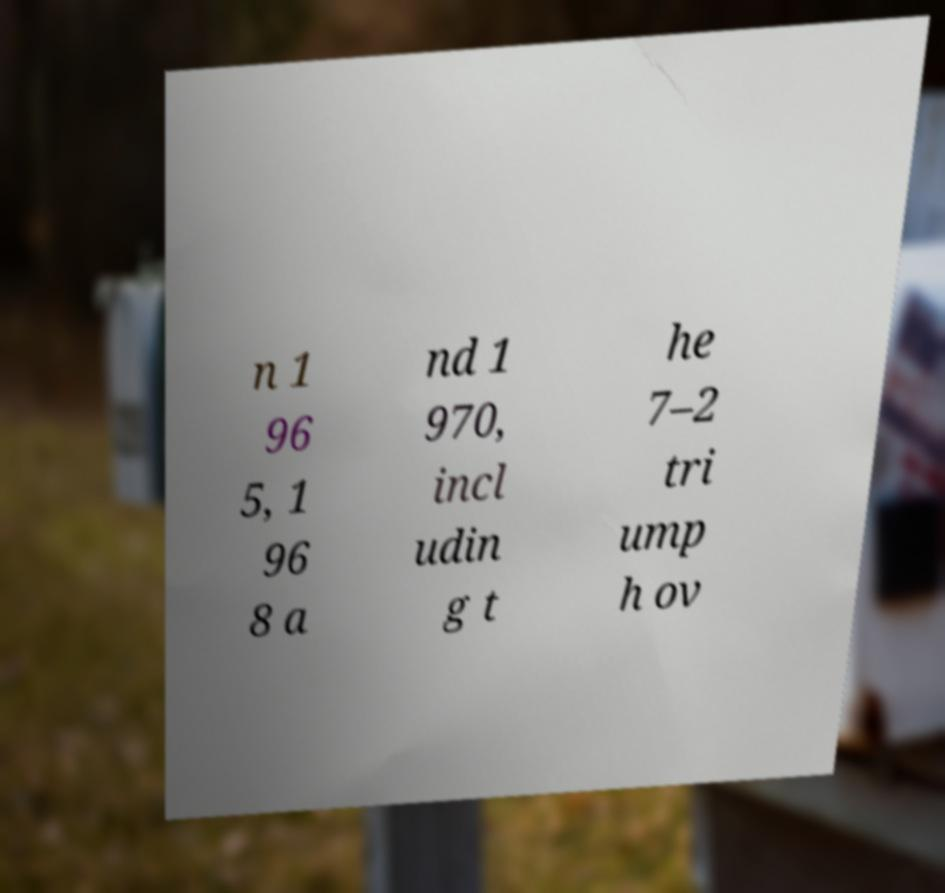There's text embedded in this image that I need extracted. Can you transcribe it verbatim? n 1 96 5, 1 96 8 a nd 1 970, incl udin g t he 7–2 tri ump h ov 